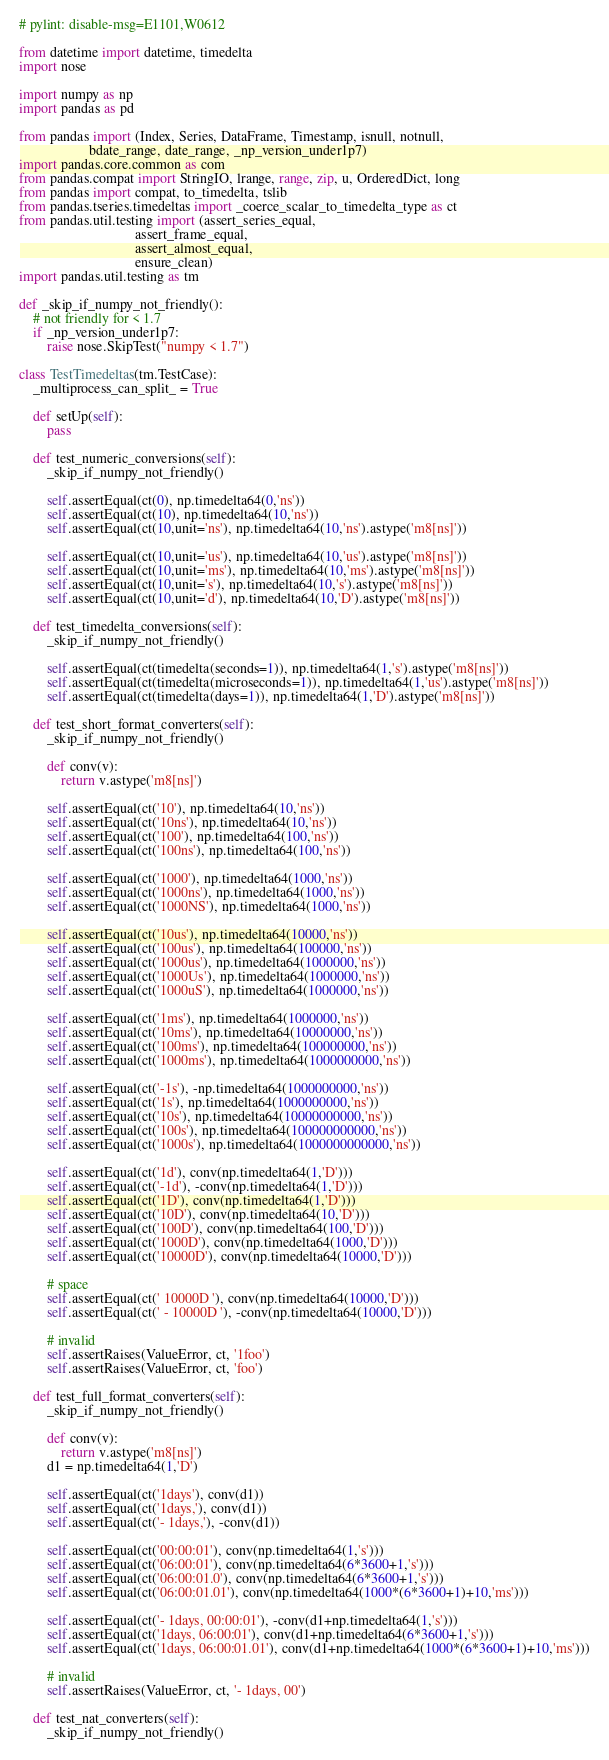<code> <loc_0><loc_0><loc_500><loc_500><_Python_># pylint: disable-msg=E1101,W0612

from datetime import datetime, timedelta
import nose

import numpy as np
import pandas as pd

from pandas import (Index, Series, DataFrame, Timestamp, isnull, notnull,
                    bdate_range, date_range, _np_version_under1p7)
import pandas.core.common as com
from pandas.compat import StringIO, lrange, range, zip, u, OrderedDict, long
from pandas import compat, to_timedelta, tslib
from pandas.tseries.timedeltas import _coerce_scalar_to_timedelta_type as ct
from pandas.util.testing import (assert_series_equal,
                                 assert_frame_equal,
                                 assert_almost_equal,
                                 ensure_clean)
import pandas.util.testing as tm

def _skip_if_numpy_not_friendly():
    # not friendly for < 1.7
    if _np_version_under1p7:
        raise nose.SkipTest("numpy < 1.7")

class TestTimedeltas(tm.TestCase):
    _multiprocess_can_split_ = True

    def setUp(self):
        pass

    def test_numeric_conversions(self):
        _skip_if_numpy_not_friendly()

        self.assertEqual(ct(0), np.timedelta64(0,'ns'))
        self.assertEqual(ct(10), np.timedelta64(10,'ns'))
        self.assertEqual(ct(10,unit='ns'), np.timedelta64(10,'ns').astype('m8[ns]'))

        self.assertEqual(ct(10,unit='us'), np.timedelta64(10,'us').astype('m8[ns]'))
        self.assertEqual(ct(10,unit='ms'), np.timedelta64(10,'ms').astype('m8[ns]'))
        self.assertEqual(ct(10,unit='s'), np.timedelta64(10,'s').astype('m8[ns]'))
        self.assertEqual(ct(10,unit='d'), np.timedelta64(10,'D').astype('m8[ns]'))

    def test_timedelta_conversions(self):
        _skip_if_numpy_not_friendly()

        self.assertEqual(ct(timedelta(seconds=1)), np.timedelta64(1,'s').astype('m8[ns]'))
        self.assertEqual(ct(timedelta(microseconds=1)), np.timedelta64(1,'us').astype('m8[ns]'))
        self.assertEqual(ct(timedelta(days=1)), np.timedelta64(1,'D').astype('m8[ns]'))

    def test_short_format_converters(self):
        _skip_if_numpy_not_friendly()

        def conv(v):
            return v.astype('m8[ns]')

        self.assertEqual(ct('10'), np.timedelta64(10,'ns'))
        self.assertEqual(ct('10ns'), np.timedelta64(10,'ns'))
        self.assertEqual(ct('100'), np.timedelta64(100,'ns'))
        self.assertEqual(ct('100ns'), np.timedelta64(100,'ns'))

        self.assertEqual(ct('1000'), np.timedelta64(1000,'ns'))
        self.assertEqual(ct('1000ns'), np.timedelta64(1000,'ns'))
        self.assertEqual(ct('1000NS'), np.timedelta64(1000,'ns'))

        self.assertEqual(ct('10us'), np.timedelta64(10000,'ns'))
        self.assertEqual(ct('100us'), np.timedelta64(100000,'ns'))
        self.assertEqual(ct('1000us'), np.timedelta64(1000000,'ns'))
        self.assertEqual(ct('1000Us'), np.timedelta64(1000000,'ns'))
        self.assertEqual(ct('1000uS'), np.timedelta64(1000000,'ns'))

        self.assertEqual(ct('1ms'), np.timedelta64(1000000,'ns'))
        self.assertEqual(ct('10ms'), np.timedelta64(10000000,'ns'))
        self.assertEqual(ct('100ms'), np.timedelta64(100000000,'ns'))
        self.assertEqual(ct('1000ms'), np.timedelta64(1000000000,'ns'))

        self.assertEqual(ct('-1s'), -np.timedelta64(1000000000,'ns'))
        self.assertEqual(ct('1s'), np.timedelta64(1000000000,'ns'))
        self.assertEqual(ct('10s'), np.timedelta64(10000000000,'ns'))
        self.assertEqual(ct('100s'), np.timedelta64(100000000000,'ns'))
        self.assertEqual(ct('1000s'), np.timedelta64(1000000000000,'ns'))

        self.assertEqual(ct('1d'), conv(np.timedelta64(1,'D')))
        self.assertEqual(ct('-1d'), -conv(np.timedelta64(1,'D')))
        self.assertEqual(ct('1D'), conv(np.timedelta64(1,'D')))
        self.assertEqual(ct('10D'), conv(np.timedelta64(10,'D')))
        self.assertEqual(ct('100D'), conv(np.timedelta64(100,'D')))
        self.assertEqual(ct('1000D'), conv(np.timedelta64(1000,'D')))
        self.assertEqual(ct('10000D'), conv(np.timedelta64(10000,'D')))

        # space
        self.assertEqual(ct(' 10000D '), conv(np.timedelta64(10000,'D')))
        self.assertEqual(ct(' - 10000D '), -conv(np.timedelta64(10000,'D')))

        # invalid
        self.assertRaises(ValueError, ct, '1foo')
        self.assertRaises(ValueError, ct, 'foo')

    def test_full_format_converters(self):
        _skip_if_numpy_not_friendly()

        def conv(v):
            return v.astype('m8[ns]')
        d1 = np.timedelta64(1,'D')

        self.assertEqual(ct('1days'), conv(d1))
        self.assertEqual(ct('1days,'), conv(d1))
        self.assertEqual(ct('- 1days,'), -conv(d1))

        self.assertEqual(ct('00:00:01'), conv(np.timedelta64(1,'s')))
        self.assertEqual(ct('06:00:01'), conv(np.timedelta64(6*3600+1,'s')))
        self.assertEqual(ct('06:00:01.0'), conv(np.timedelta64(6*3600+1,'s')))
        self.assertEqual(ct('06:00:01.01'), conv(np.timedelta64(1000*(6*3600+1)+10,'ms')))

        self.assertEqual(ct('- 1days, 00:00:01'), -conv(d1+np.timedelta64(1,'s')))
        self.assertEqual(ct('1days, 06:00:01'), conv(d1+np.timedelta64(6*3600+1,'s')))
        self.assertEqual(ct('1days, 06:00:01.01'), conv(d1+np.timedelta64(1000*(6*3600+1)+10,'ms')))

        # invalid
        self.assertRaises(ValueError, ct, '- 1days, 00')

    def test_nat_converters(self):
        _skip_if_numpy_not_friendly()
</code> 